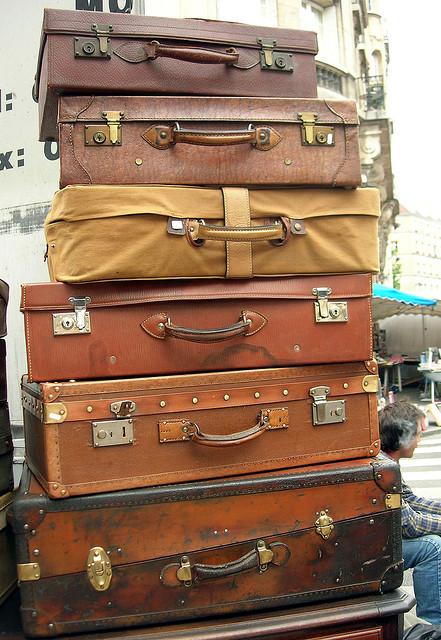What are they?
Write a very short answer. Suitcases. What color are the suitcases?
Be succinct. Brown. How many black briefcases?
Concise answer only. 0. 